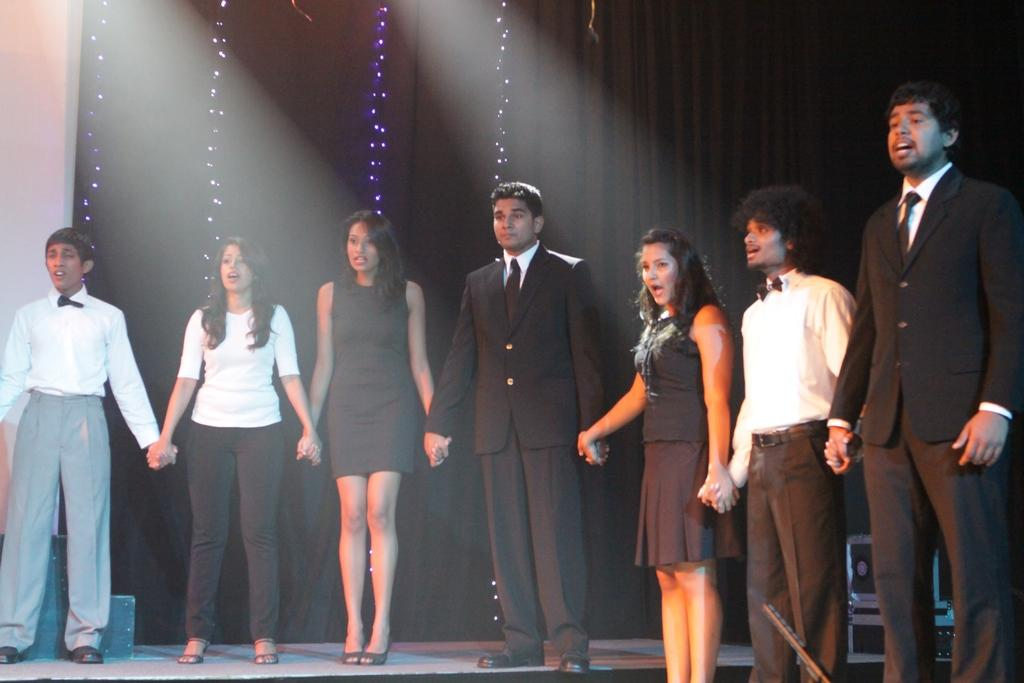What is happening in the image? There is a group of people standing on a stage in the image. What can be seen in the background of the image? There are lights and a wall visible in the background of the image. What type of poison is being served to the people on the stage? There is no mention of poison or serving in the image; it simply shows a group of people standing on a stage. 